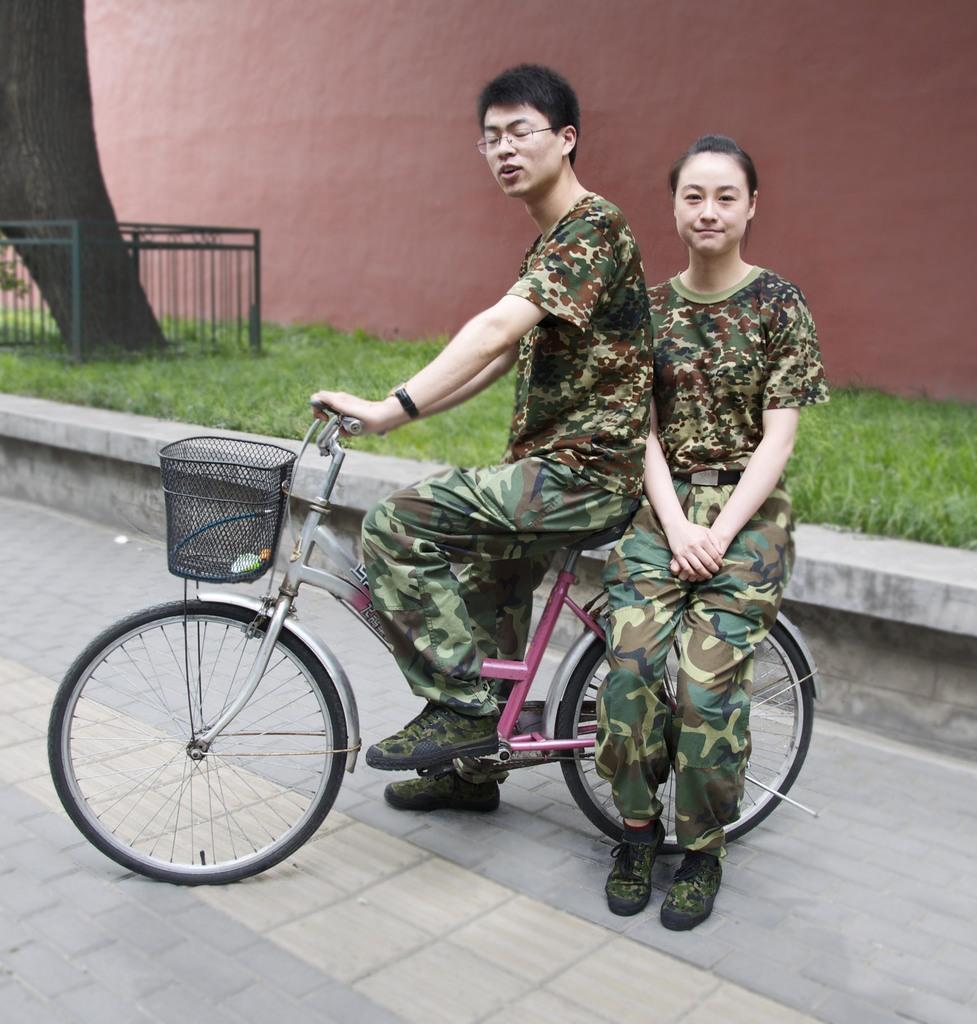Who or what can be seen in the image? There are people in the image. What are the people doing in the image? The people are sitting on bicycles. What type of development can be seen in the background of the image? There is no background or development visible in the image; it only shows people sitting on bicycles. 